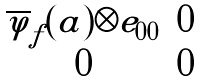Convert formula to latex. <formula><loc_0><loc_0><loc_500><loc_500>\begin{matrix} \overline { \varphi } _ { f } ( a ) \otimes e _ { 0 0 } & 0 \\ 0 & 0 \end{matrix}</formula> 